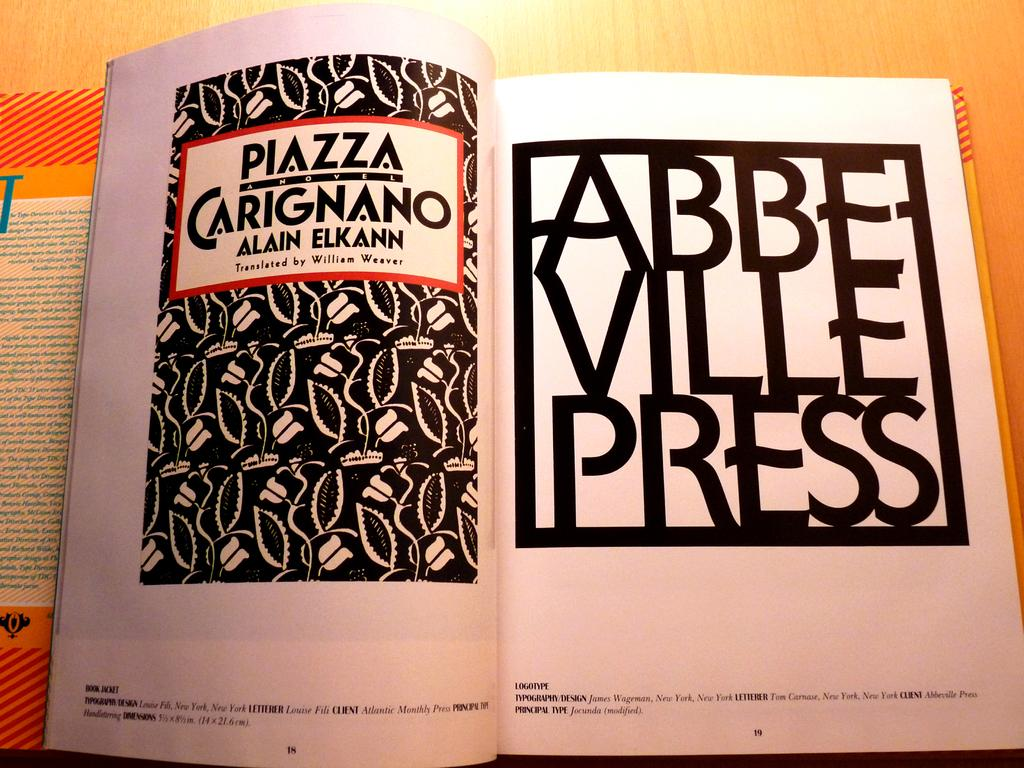<image>
Create a compact narrative representing the image presented. The book Piazza Carignano was written by Alain Elkann. 